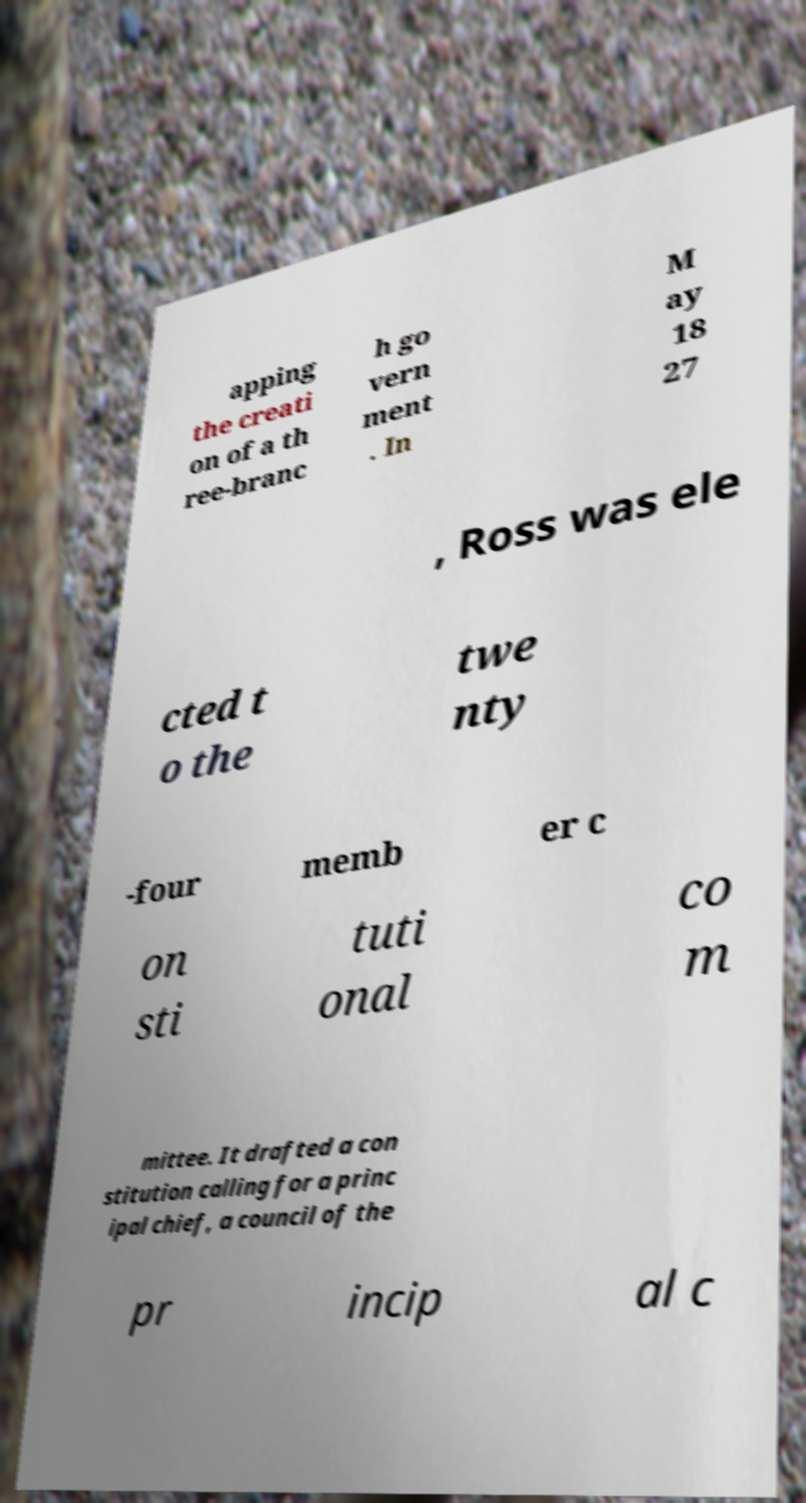For documentation purposes, I need the text within this image transcribed. Could you provide that? apping the creati on of a th ree-branc h go vern ment . In M ay 18 27 , Ross was ele cted t o the twe nty -four memb er c on sti tuti onal co m mittee. It drafted a con stitution calling for a princ ipal chief, a council of the pr incip al c 